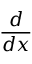Convert formula to latex. <formula><loc_0><loc_0><loc_500><loc_500>\frac { d } { d x }</formula> 